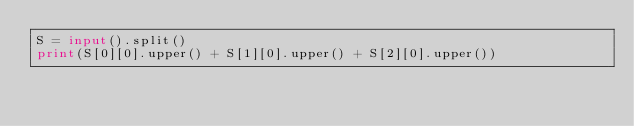Convert code to text. <code><loc_0><loc_0><loc_500><loc_500><_Python_>S = input().split() 
print(S[0][0].upper() + S[1][0].upper() + S[2][0].upper())</code> 